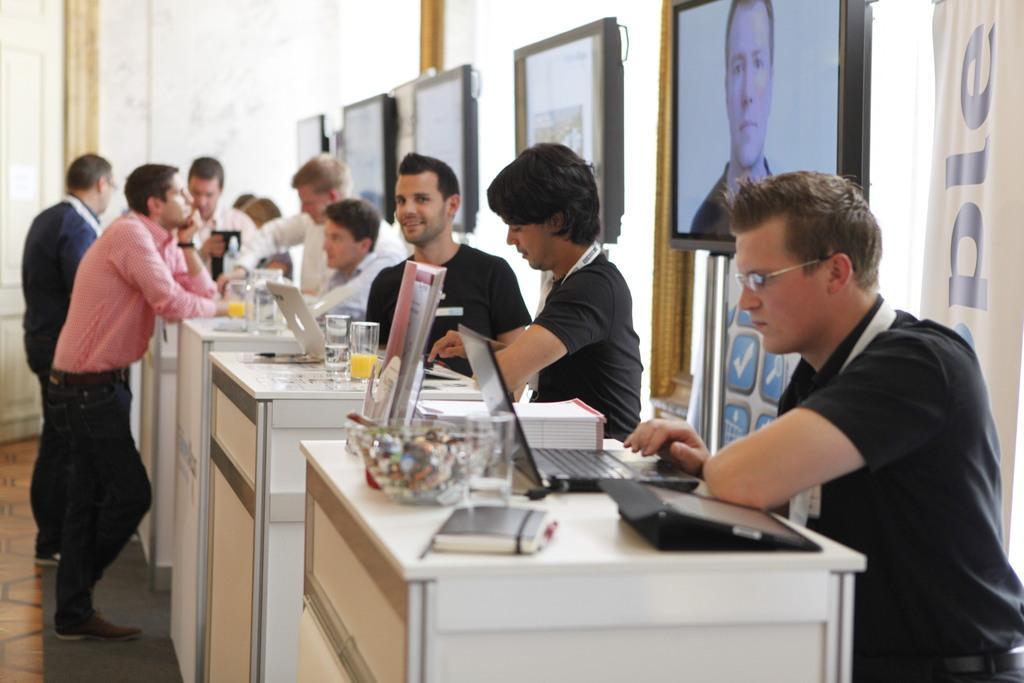How would you summarize this image in a sentence or two? This picture shows few people standing with the laptops on the table 